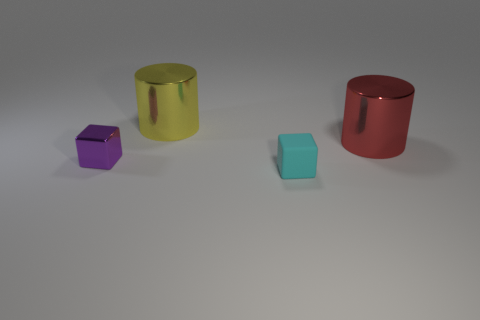Add 3 red metal cylinders. How many objects exist? 7 Subtract all purple blocks. How many blocks are left? 1 Subtract 2 cubes. How many cubes are left? 0 Subtract all blue cylinders. How many purple cubes are left? 1 Add 2 yellow shiny cylinders. How many yellow shiny cylinders exist? 3 Subtract 0 gray spheres. How many objects are left? 4 Subtract all brown cylinders. Subtract all gray cubes. How many cylinders are left? 2 Subtract all small purple metal objects. Subtract all yellow things. How many objects are left? 2 Add 1 rubber objects. How many rubber objects are left? 2 